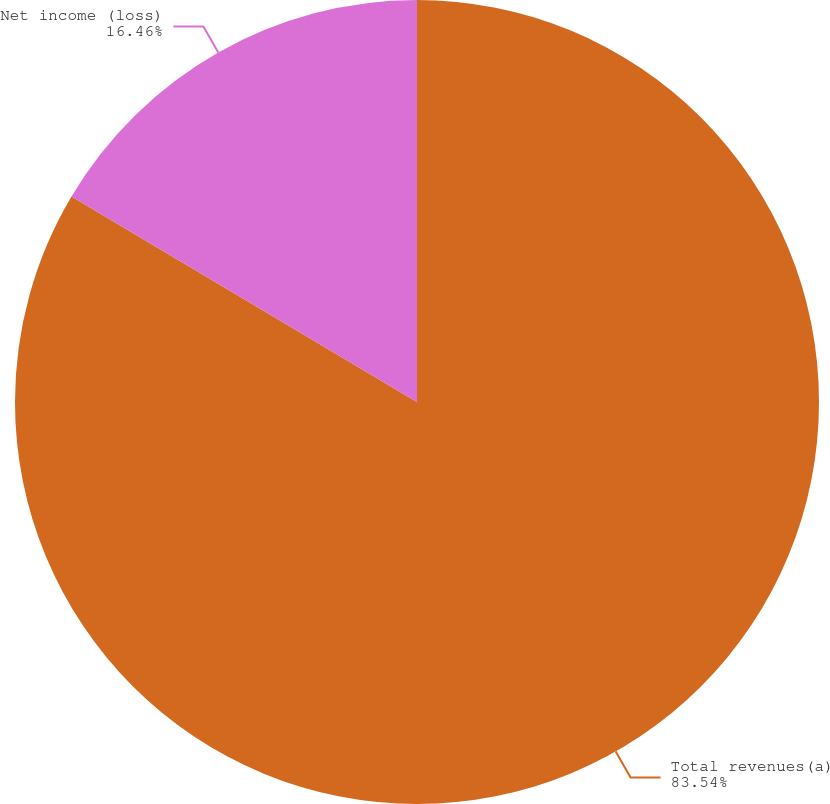<chart> <loc_0><loc_0><loc_500><loc_500><pie_chart><fcel>Total revenues(a)<fcel>Net income (loss)<nl><fcel>83.54%<fcel>16.46%<nl></chart> 